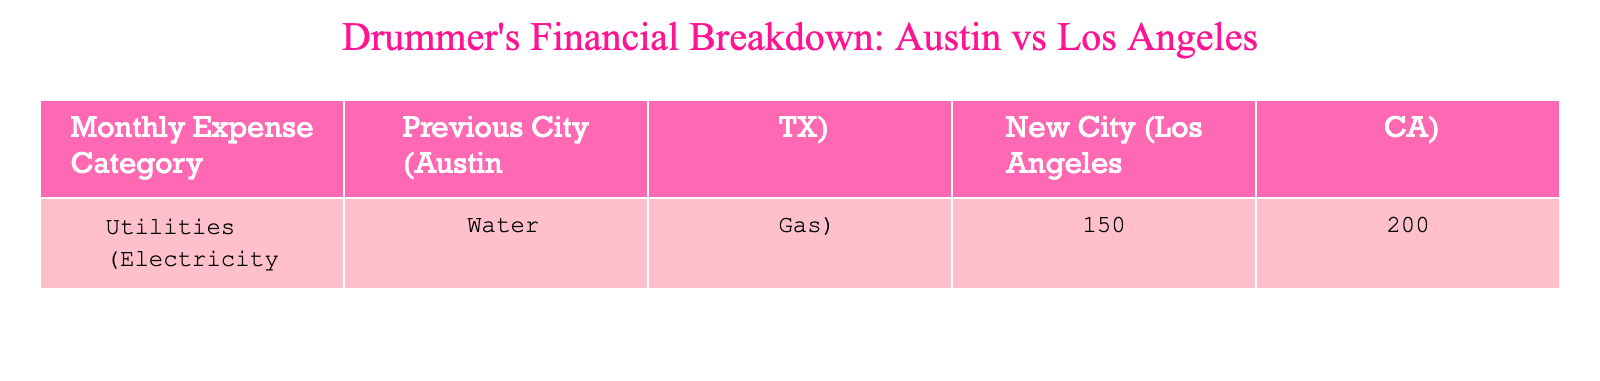What are the utility costs in the previous city? From the table, the utility costs in the previous city (Austin, TX) are given as 150.
Answer: 150 What are the utility costs in the new city? According to the table, the utility costs in the new city (Los Angeles, CA) are 200.
Answer: 200 How much more do you pay for utilities in Los Angeles compared to Austin? To find the difference, subtract the utility costs in Austin from those in Los Angeles: 200 - 150 = 50.
Answer: 50 Is the utility cost in Los Angeles greater than in Austin? By comparing the utility costs, since 200 is greater than 150, we conclude that this statement is true.
Answer: Yes What is the total cost for utilities in both cities combined? To find the total, add the utility costs of both cities: 150 (Austin) + 200 (Los Angeles) = 350.
Answer: 350 Which city has higher living costs for utilities? The table shows that the utility cost is higher in Los Angeles (200) than in Austin (150), so Los Angeles has higher living costs for utilities.
Answer: Los Angeles If you were to budget for utilities for six months in Los Angeles, how much would that be? Multiply the monthly utility cost in Los Angeles (200) by 6 months: 200 * 6 = 1200.
Answer: 1200 What percentage increase in utility cost did you experience moving from Austin to Los Angeles? To find the percentage increase, use the formula: [(New Cost - Old Cost) / Old Cost] * 100. This results in: [(200 - 150) / 150] * 100 = 33.33%.
Answer: 33.33% What is the average monthly utility cost between the two cities? To find the average, add the utility costs and divide by 2: (150 + 200) / 2 = 175.
Answer: 175 